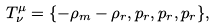Convert formula to latex. <formula><loc_0><loc_0><loc_500><loc_500>T _ { \nu } ^ { \mu } = \{ - \rho _ { m } - \rho _ { r } , p _ { r } , p _ { r } , p _ { r } \} ,</formula> 